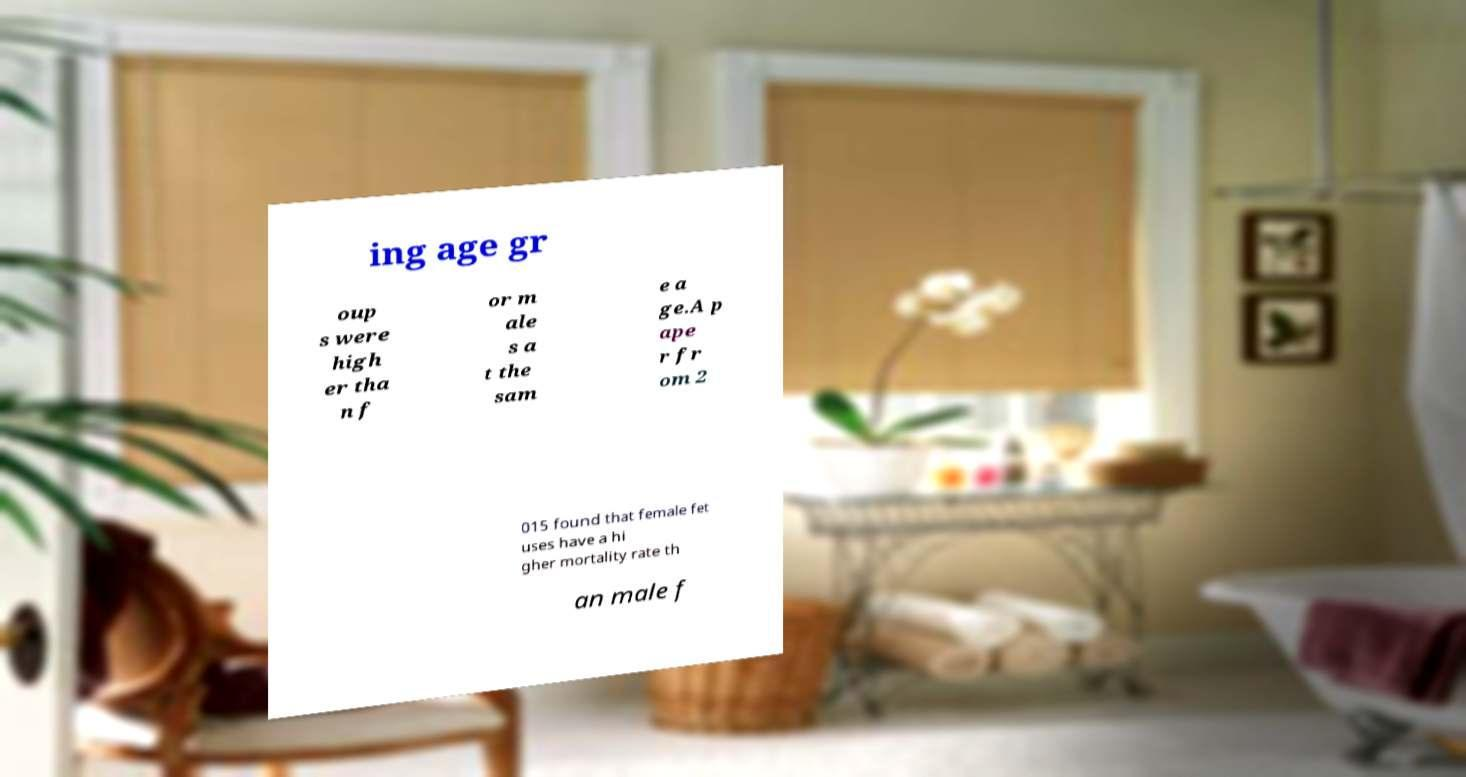What messages or text are displayed in this image? I need them in a readable, typed format. ing age gr oup s were high er tha n f or m ale s a t the sam e a ge.A p ape r fr om 2 015 found that female fet uses have a hi gher mortality rate th an male f 